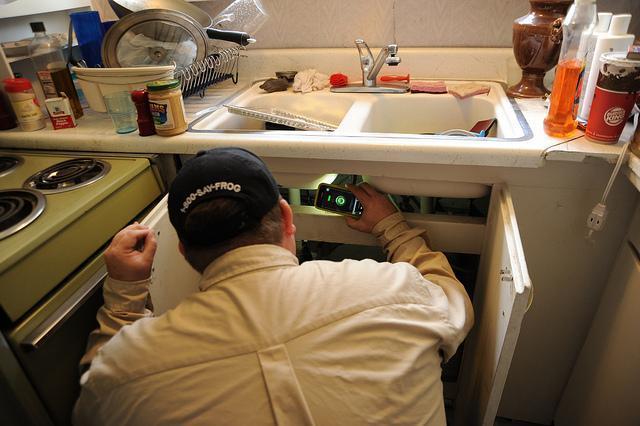What is the man using the phone as?
Select the accurate answer and provide justification: `Answer: choice
Rationale: srationale.`
Options: Flash light, speaker, television, blender. Answer: flash light.
Rationale: The man is using the phone as a flash light to see. 